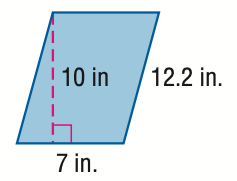Answer the mathemtical geometry problem and directly provide the correct option letter.
Question: Find the area of the parallelogram. Round to the nearest tenth if necessary.
Choices: A: 35 B: 38.4 C: 70 D: 140 C 